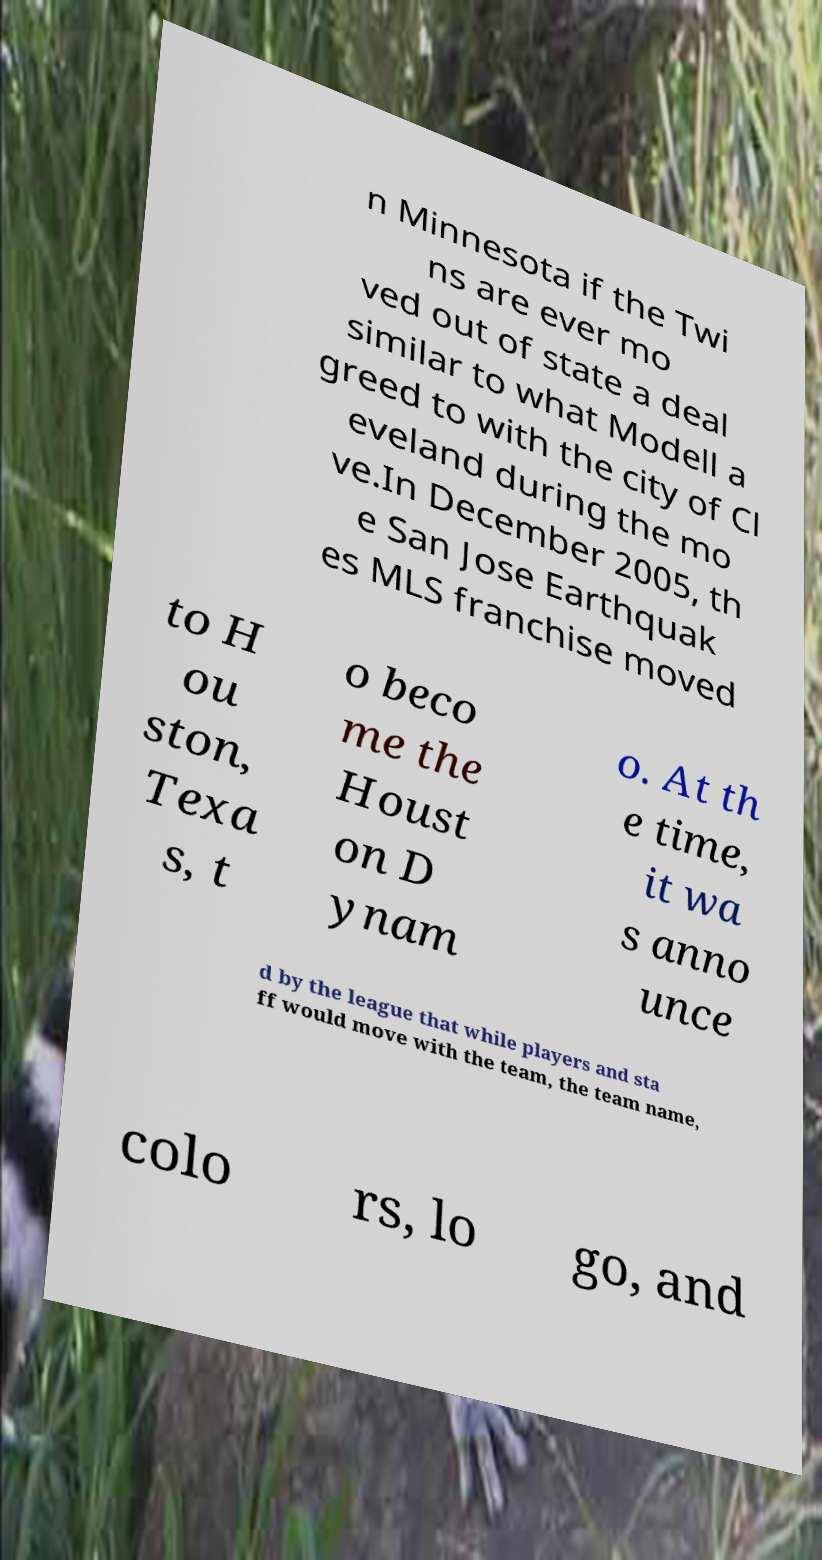Could you assist in decoding the text presented in this image and type it out clearly? n Minnesota if the Twi ns are ever mo ved out of state a deal similar to what Modell a greed to with the city of Cl eveland during the mo ve.In December 2005, th e San Jose Earthquak es MLS franchise moved to H ou ston, Texa s, t o beco me the Houst on D ynam o. At th e time, it wa s anno unce d by the league that while players and sta ff would move with the team, the team name, colo rs, lo go, and 